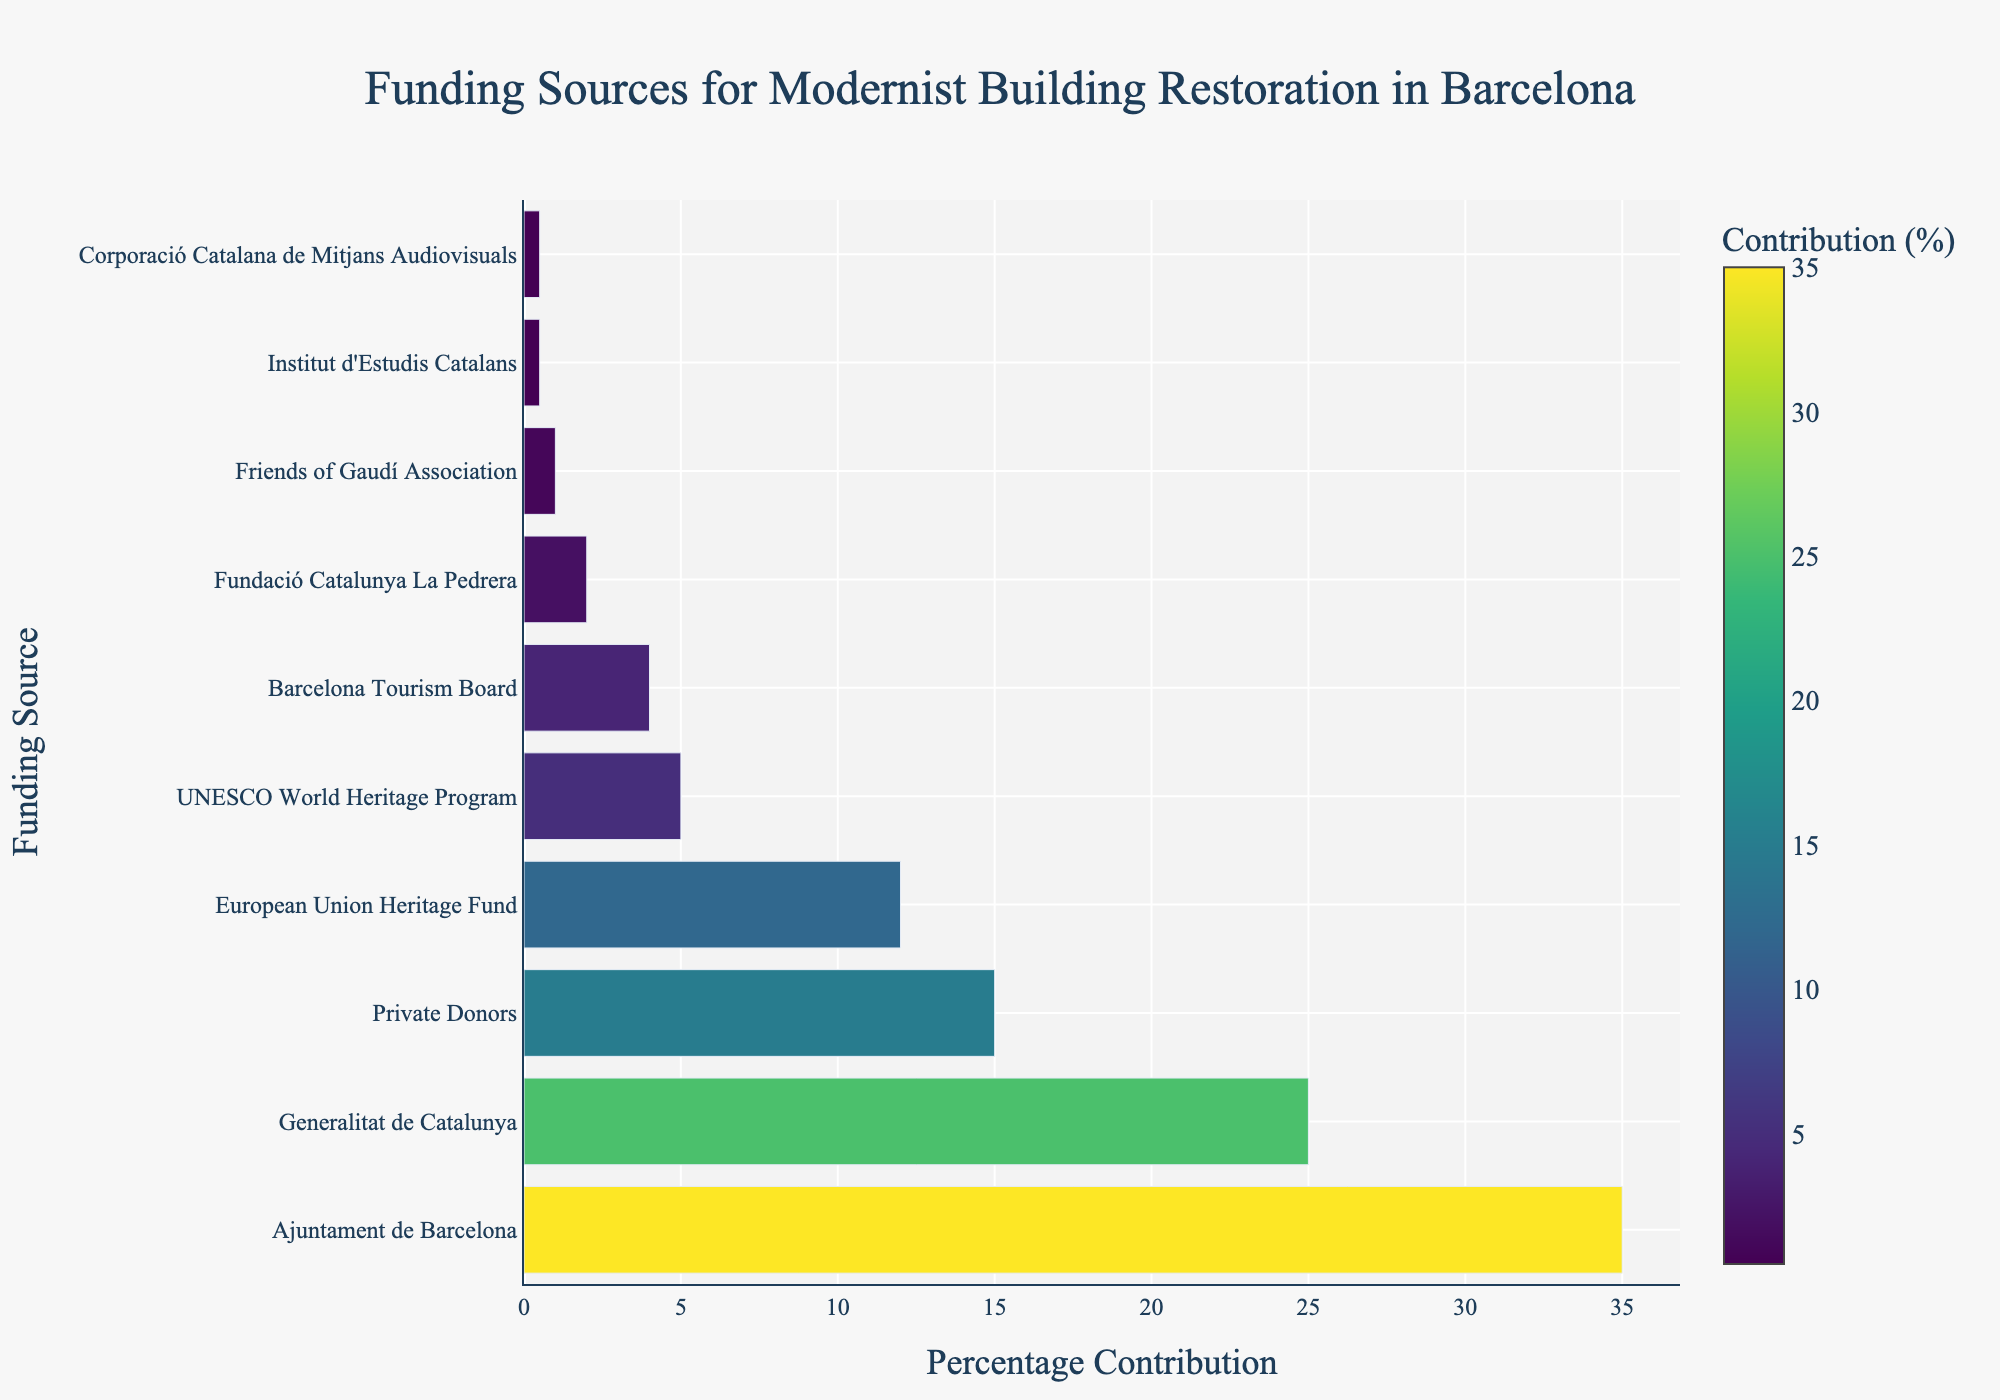Which funding source contributes the most to the restoration of modernist buildings in Barcelona? The tallest bar represents the funding source with the highest percentage contribution. From the chart, Ajuntament de Barcelona has the tallest bar.
Answer: Ajuntament de Barcelona Which funding source contributes the least to the restoration of modernist buildings in Barcelona? The shortest bars represent the funding sources with the least percentage contribution. From the chart, both Institut d'Estudis Catalans and Corporació Catalana de Mitjans Audiovisuals have the shortest bars.
Answer: Institut d'Estudis Catalans and Corporació Catalana de Mitjans Audiovisuals How much more does Ajuntament de Barcelona contribute compared to European Union Heritage Fund? Ajuntament de Barcelona contributes 35%, and European Union Heritage Fund contributes 12%. The difference is 35% - 12%.
Answer: 23% What is the combined percentage contribution of Generalitat de Catalunya, UNESCO World Heritage Program, and Fundació Catalunya La Pedrera? Sum the contributions: Generalitat de Catalunya (25%) + UNESCO World Heritage Program (5%) + Fundació Catalunya La Pedrera (2%). 25% + 5% + 2% = 32%.
Answer: 32% Which funding source is represented with the second-highest percentage contribution? The second tallest bar after Ajuntament de Barcelona is Generalitat de Catalunya, which represents the second-highest percentage contribution.
Answer: Generalitat de Catalunya How much do private donors and the Barcelona Tourism Board contribute combined? Private Donors contribute 15% and Barcelona Tourism Board contribute 4%. Sum them together, 15% + 4% = 19%.
Answer: 19% Is the percentage contribution from the European Union Heritage Fund greater than that from the UNESCO World Heritage Program? The bar for European Union Heritage Fund is taller than the bar for UNESCO World Heritage Program, showing a contribution of 12% vs. 5%.
Answer: Yes Which funding source contributes exactly half the percentage of Ajuntament de Barcelona? The Ajuntament de Barcelona contributes 35%, and half of this is 35% / 2 = 17.5%. None of the funding sources contribute exactly 17.5%.
Answer: None If Fundació Catalunya La Pedrera increased its funding by 1%, where would its rank be in terms of percentage contribution? Current contribution is 2%, increasing by 1% makes it 3%. It would still rank higher than Friends of Gaudí Association (1%) but lower than Barcelona Tourism Board (4%).
Answer: 7th 